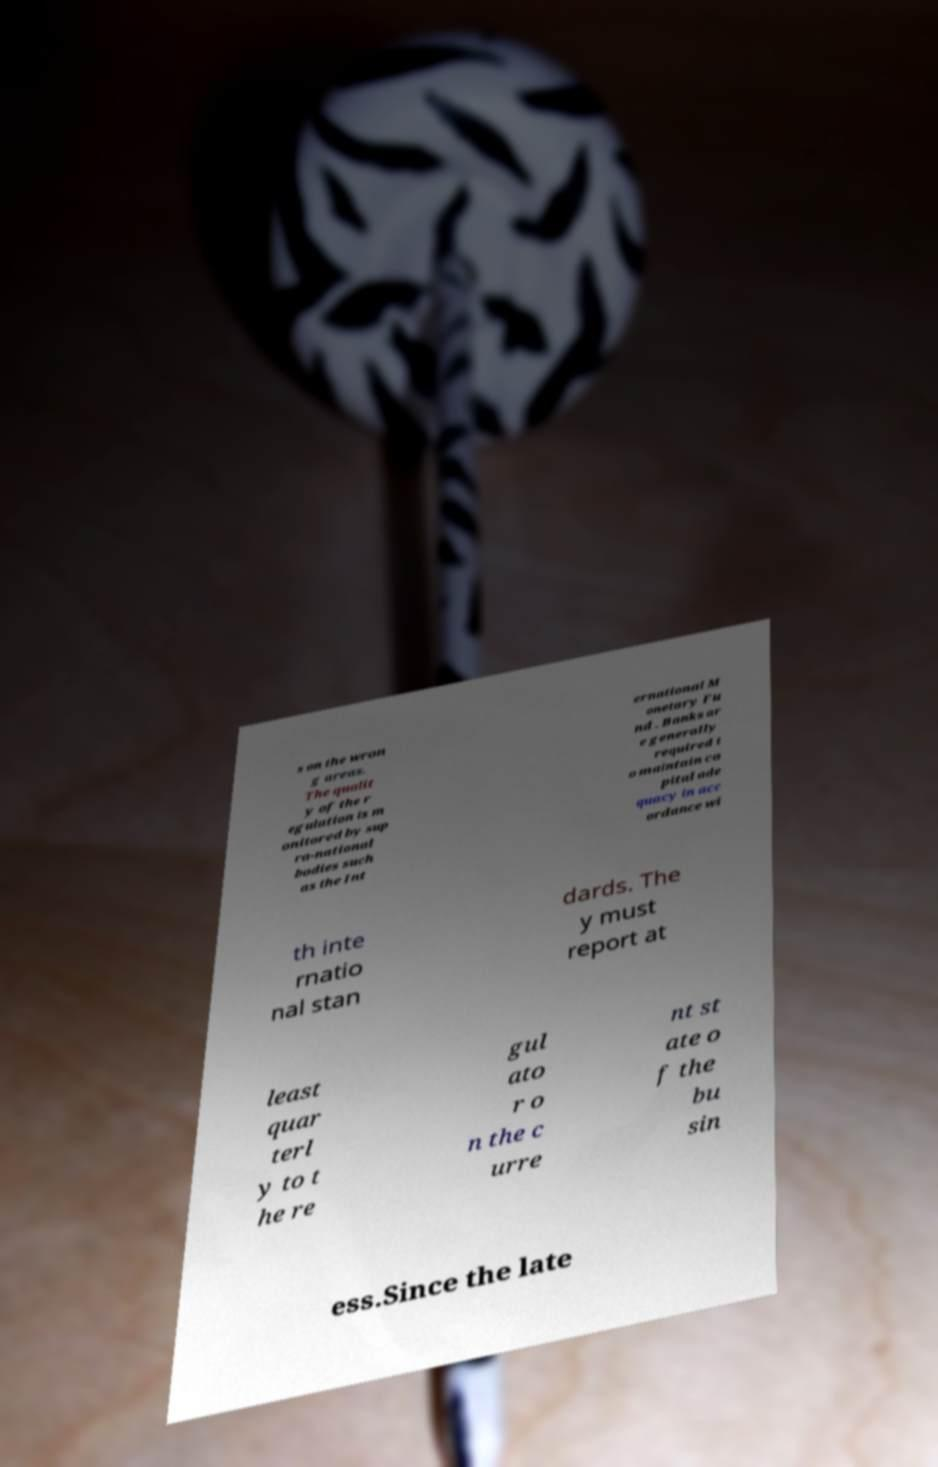There's text embedded in this image that I need extracted. Can you transcribe it verbatim? s on the wron g areas. The qualit y of the r egulation is m onitored by sup ra-national bodies such as the Int ernational M onetary Fu nd . Banks ar e generally required t o maintain ca pital ade quacy in acc ordance wi th inte rnatio nal stan dards. The y must report at least quar terl y to t he re gul ato r o n the c urre nt st ate o f the bu sin ess.Since the late 